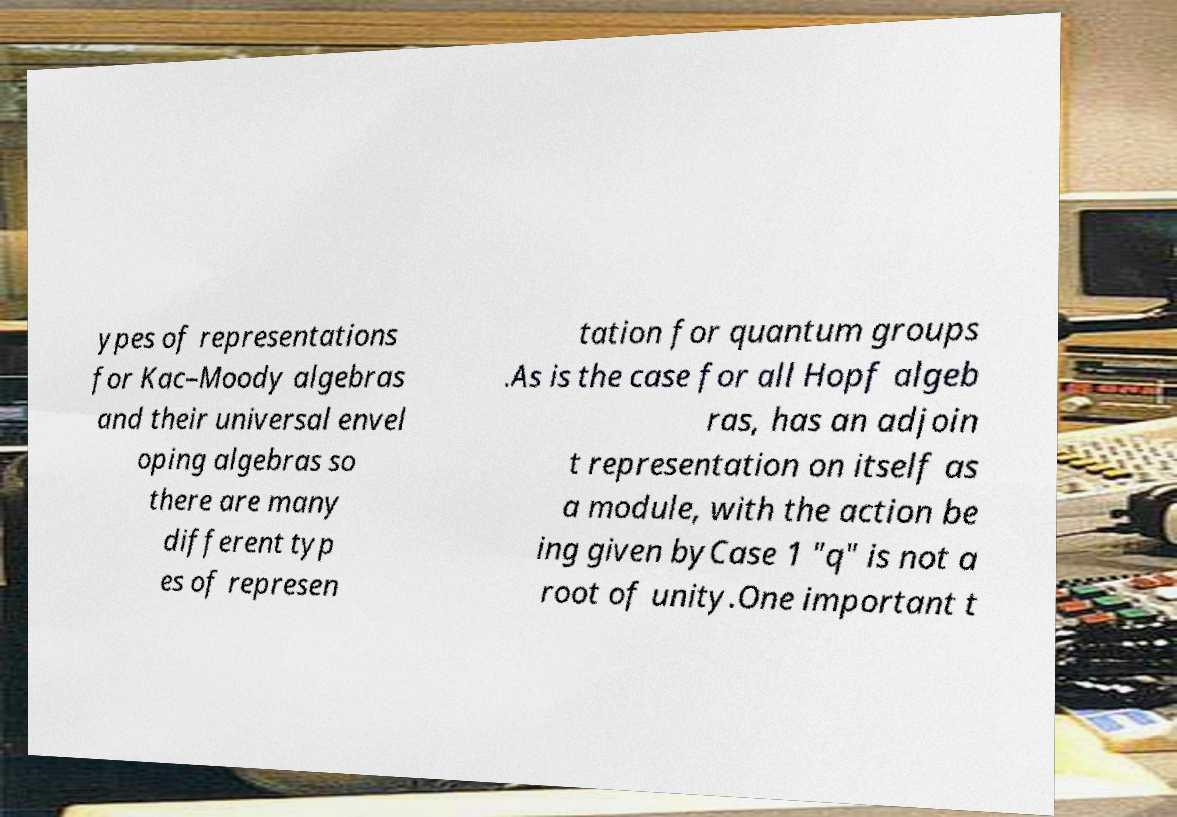Please identify and transcribe the text found in this image. ypes of representations for Kac–Moody algebras and their universal envel oping algebras so there are many different typ es of represen tation for quantum groups .As is the case for all Hopf algeb ras, has an adjoin t representation on itself as a module, with the action be ing given byCase 1 "q" is not a root of unity.One important t 